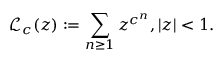Convert formula to latex. <formula><loc_0><loc_0><loc_500><loc_500>{ \mathcal { L } } _ { c } ( z ) \colon = \sum _ { n \geq 1 } z ^ { c ^ { n } } , | z | < 1 .</formula> 